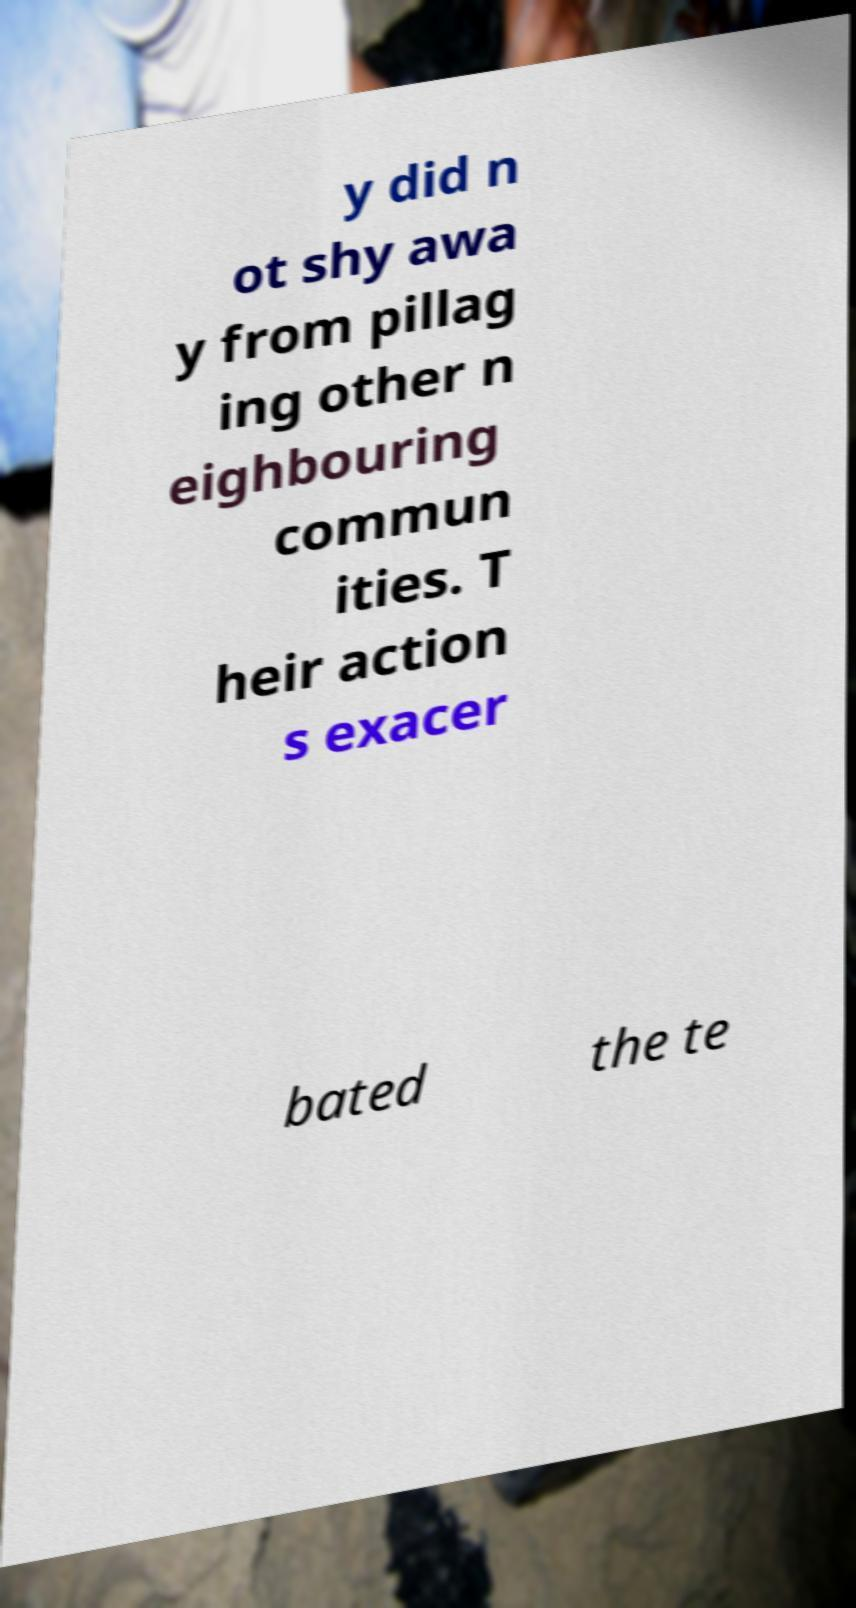Could you extract and type out the text from this image? y did n ot shy awa y from pillag ing other n eighbouring commun ities. T heir action s exacer bated the te 